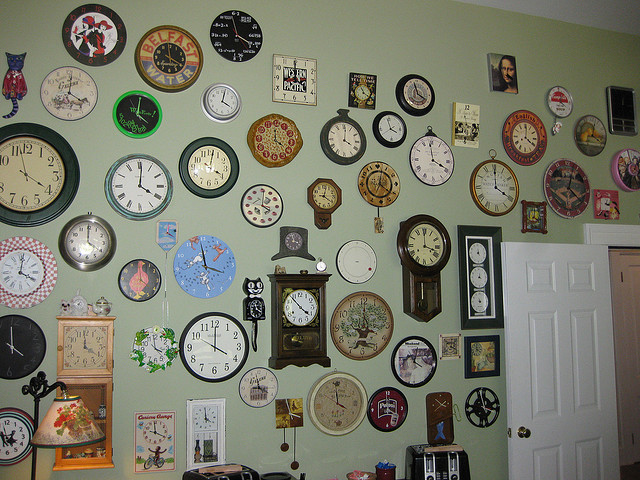Are there any clocks that show a time outside the ordinary 1-12 range? Yes, there is at least one clock designed with numbers beyond the usual 1-12 range, showcasing a unique artistic interpretation of timekeeping. 